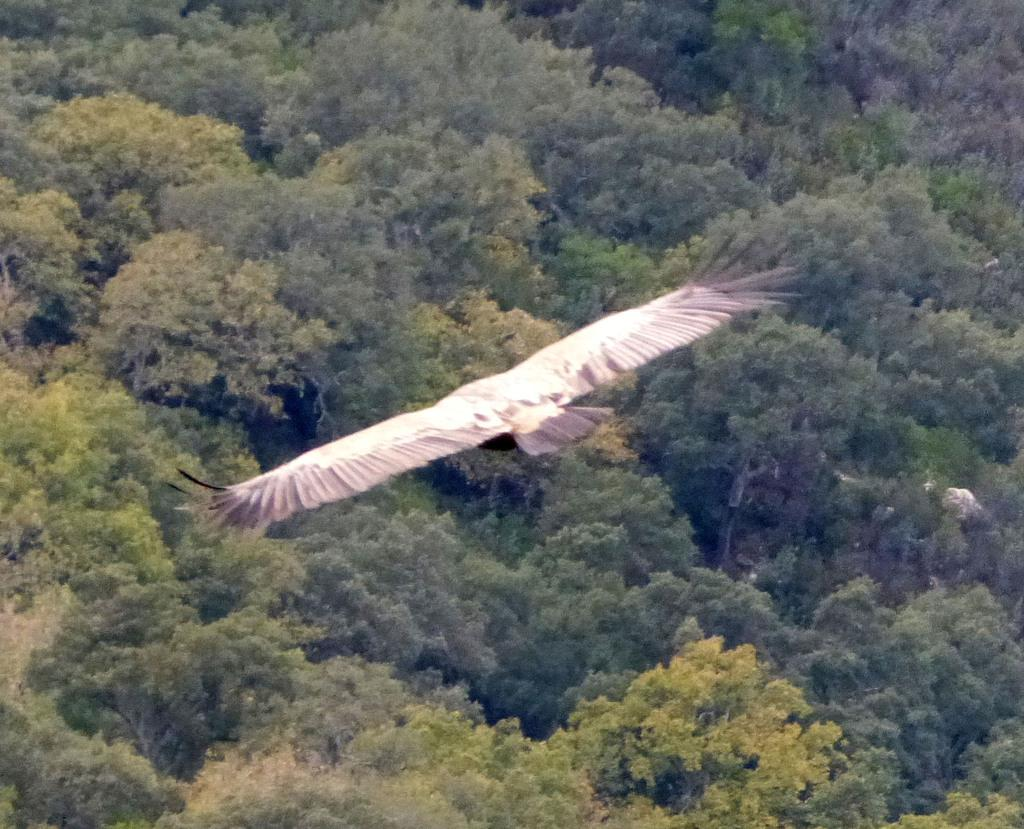What type of animal can be seen in the image? There is a bird in the image. What is the bird doing in the image? The bird is flying in the air. What can be seen in the background of the image? There are trees in the background of the image. What type of learning is the bird engaged in while flying in the image? The bird is not engaged in any learning while flying in the image; it is simply flying. 